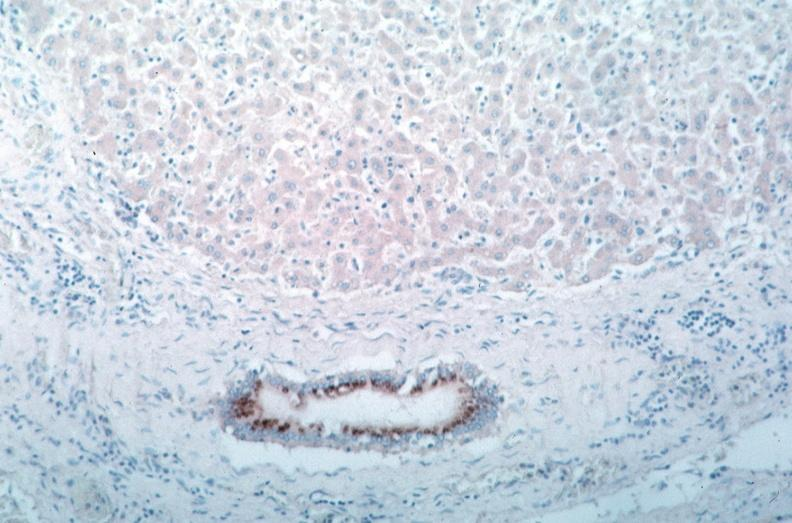s rocky mountain spotted fever, immunoperoxidase staining vessels for rickettsia rickettsii?
Answer the question using a single word or phrase. Yes 